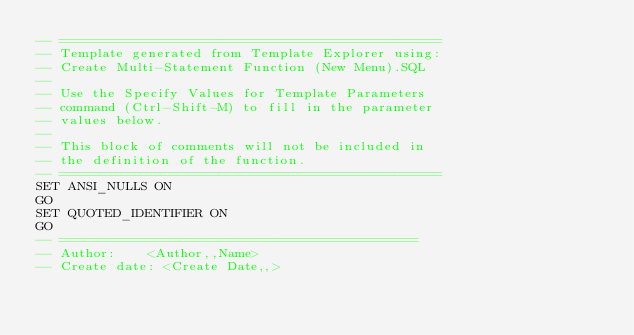Convert code to text. <code><loc_0><loc_0><loc_500><loc_500><_SQL_>-- ================================================
-- Template generated from Template Explorer using:
-- Create Multi-Statement Function (New Menu).SQL
--
-- Use the Specify Values for Template Parameters 
-- command (Ctrl-Shift-M) to fill in the parameter 
-- values below.
--
-- This block of comments will not be included in
-- the definition of the function.
-- ================================================
SET ANSI_NULLS ON
GO
SET QUOTED_IDENTIFIER ON
GO
-- =============================================
-- Author:		<Author,,Name>
-- Create date: <Create Date,,></code> 